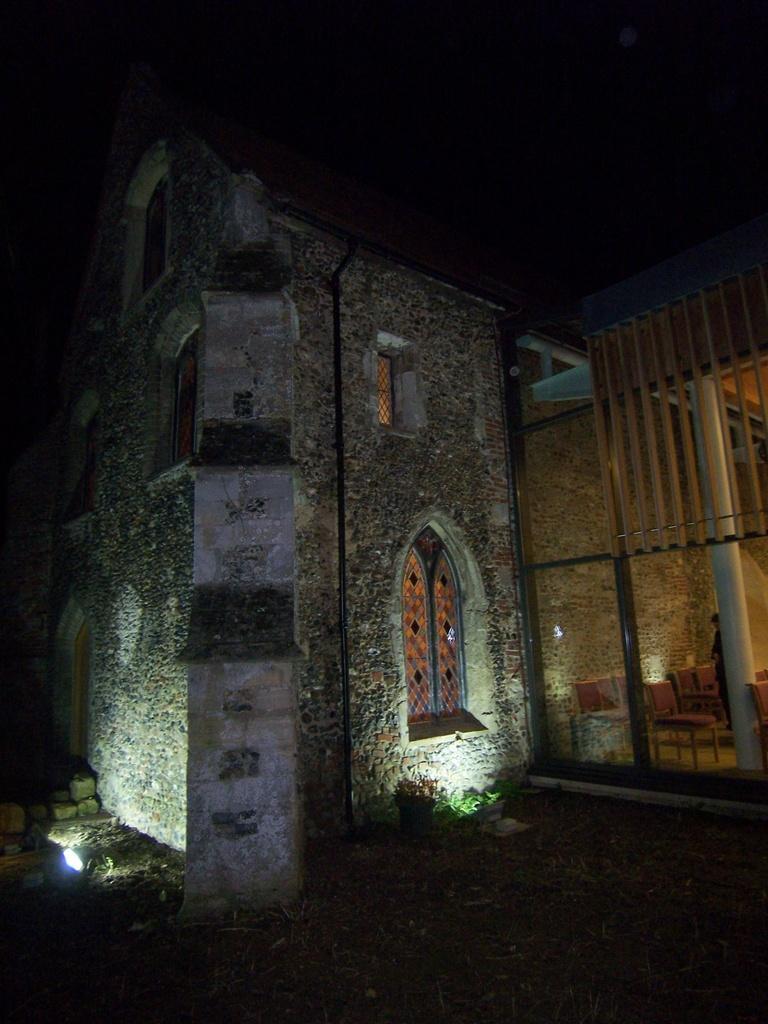Describe this image in one or two sentences. There is a building which has two lights at the bottom of it. 